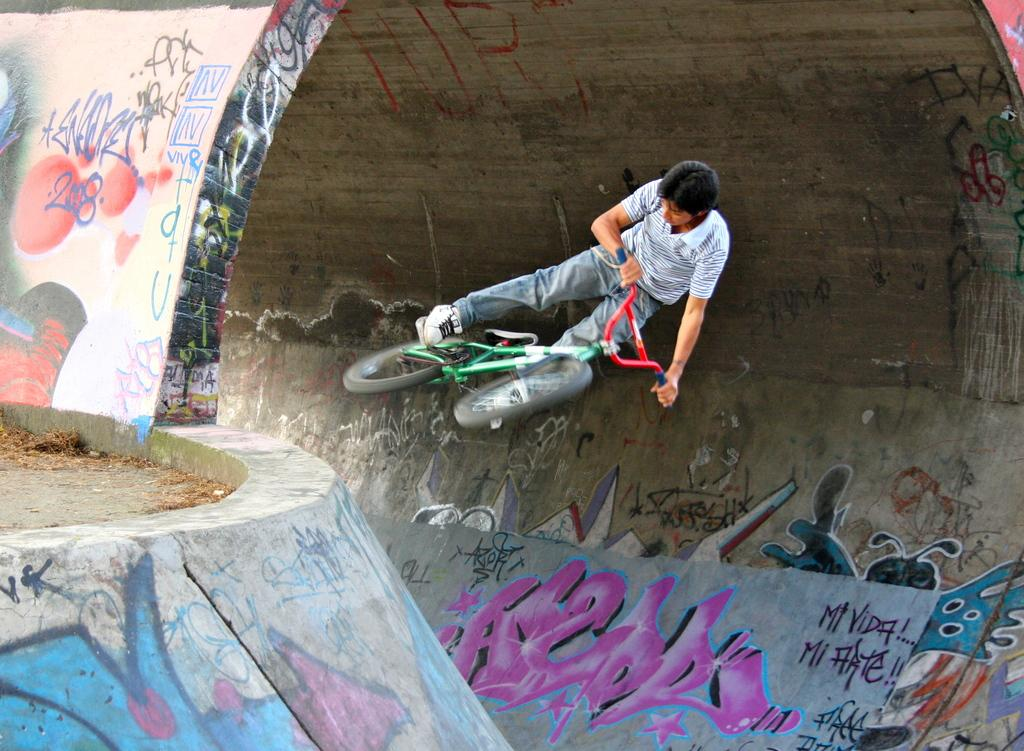What is the person in the image doing? There is a person riding a bicycle in the image. What colors are visible on the bicycle? The bicycle is green and red in color. What type of artwork can be seen on a wall in the image? There is graffiti art on a wall in the image. What color is the graffiti art? The graffiti art is pink in color. Can you tell me what type of dress the goat is wearing in the image? There is no goat or dress present in the image. What type of boat can be seen in the image? There is no boat present in the image. 